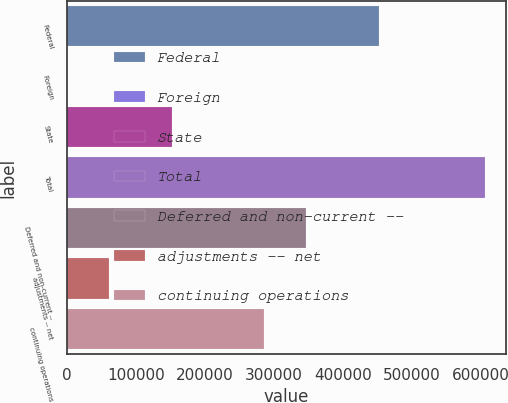Convert chart. <chart><loc_0><loc_0><loc_500><loc_500><bar_chart><fcel>Federal<fcel>Foreign<fcel>State<fcel>Total<fcel>Deferred and non-current --<fcel>adjustments -- net<fcel>continuing operations<nl><fcel>452713<fcel>130<fcel>152711<fcel>605554<fcel>346805<fcel>60672.4<fcel>286263<nl></chart> 